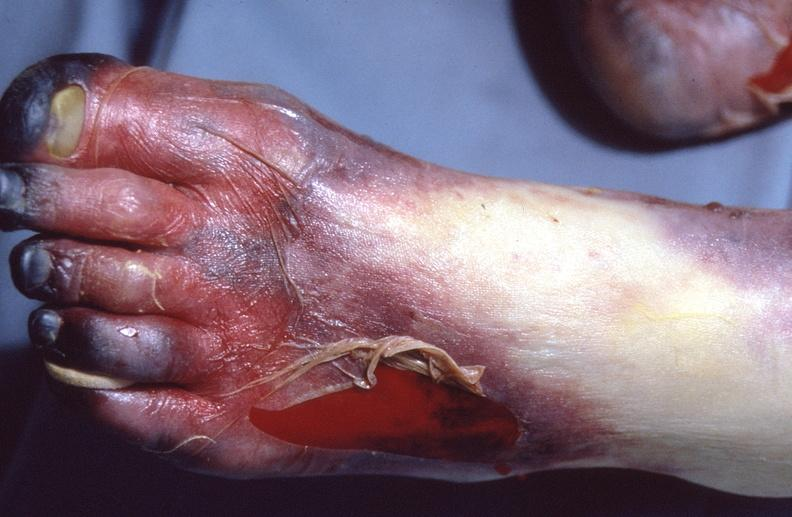what does this image show?
Answer the question using a single word or phrase. Skin ulceration and necrosis 